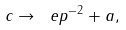<formula> <loc_0><loc_0><loc_500><loc_500>c \to \ e p ^ { - 2 } + a ,</formula> 